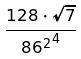Convert formula to latex. <formula><loc_0><loc_0><loc_500><loc_500>\frac { 1 2 8 \cdot \sqrt { 7 } } { { 8 6 ^ { 2 } } ^ { 4 } }</formula> 